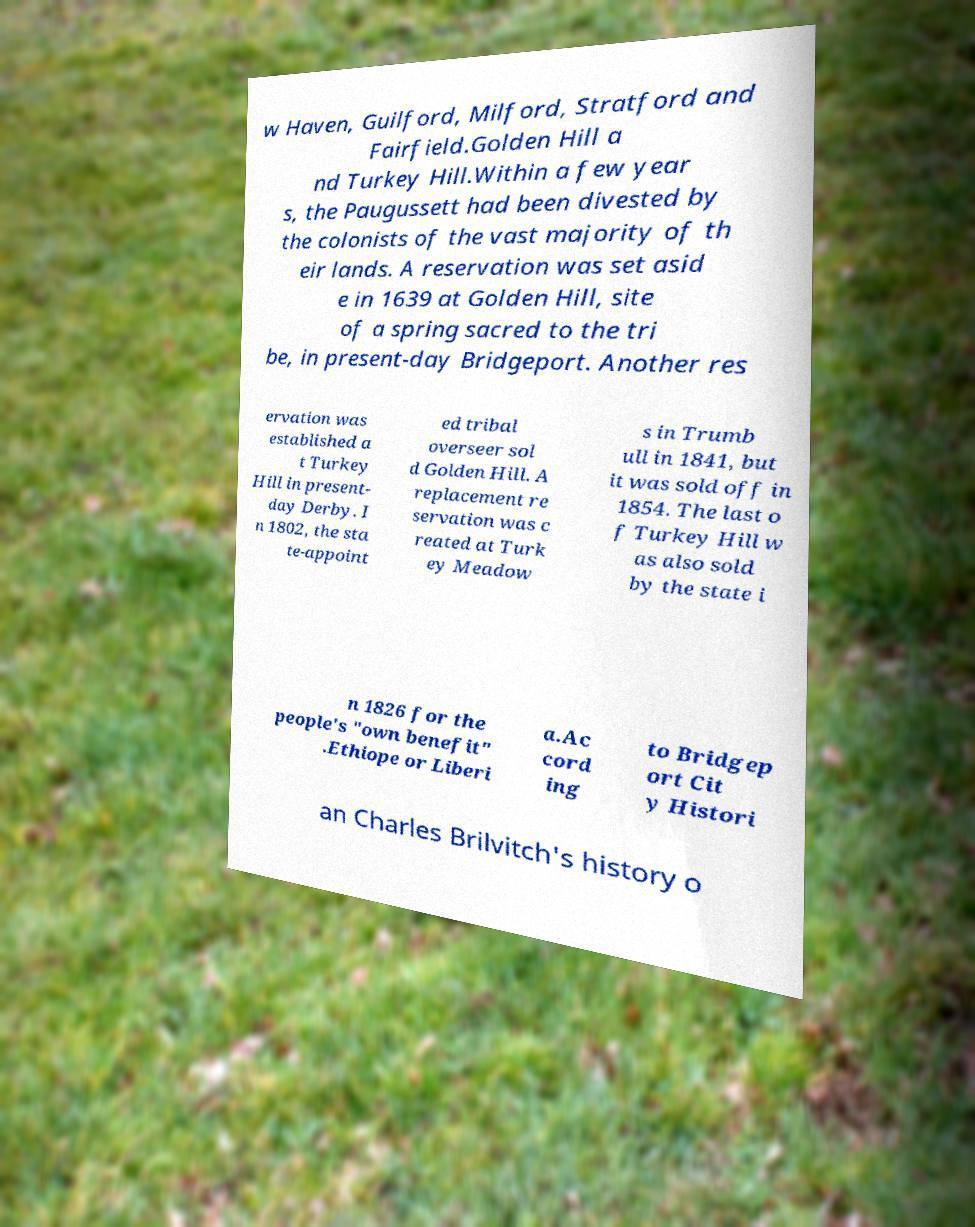What messages or text are displayed in this image? I need them in a readable, typed format. w Haven, Guilford, Milford, Stratford and Fairfield.Golden Hill a nd Turkey Hill.Within a few year s, the Paugussett had been divested by the colonists of the vast majority of th eir lands. A reservation was set asid e in 1639 at Golden Hill, site of a spring sacred to the tri be, in present-day Bridgeport. Another res ervation was established a t Turkey Hill in present- day Derby. I n 1802, the sta te-appoint ed tribal overseer sol d Golden Hill. A replacement re servation was c reated at Turk ey Meadow s in Trumb ull in 1841, but it was sold off in 1854. The last o f Turkey Hill w as also sold by the state i n 1826 for the people's "own benefit" .Ethiope or Liberi a.Ac cord ing to Bridgep ort Cit y Histori an Charles Brilvitch's history o 